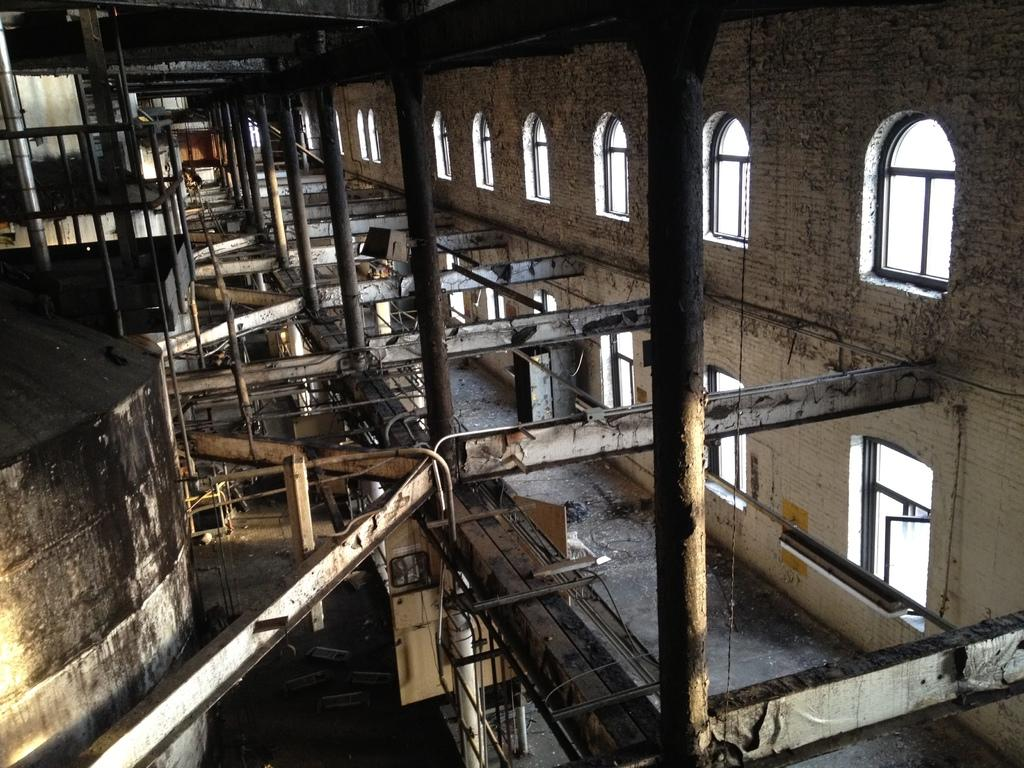What type of view is shown in the image? The image is an inside view. What architectural features can be seen in the image? There are many pillars in the image. What type of objects are on the floor in the image? There are metal objects on the floor. What is on the left side of the image? There is a wall on the left side of the image. What can be seen on the right side of the wall? There are many windows on the right side of the wall. What type of advice can be seen written on the band playing in the image? There is no band present in the image, so no advice can be seen written on it. 